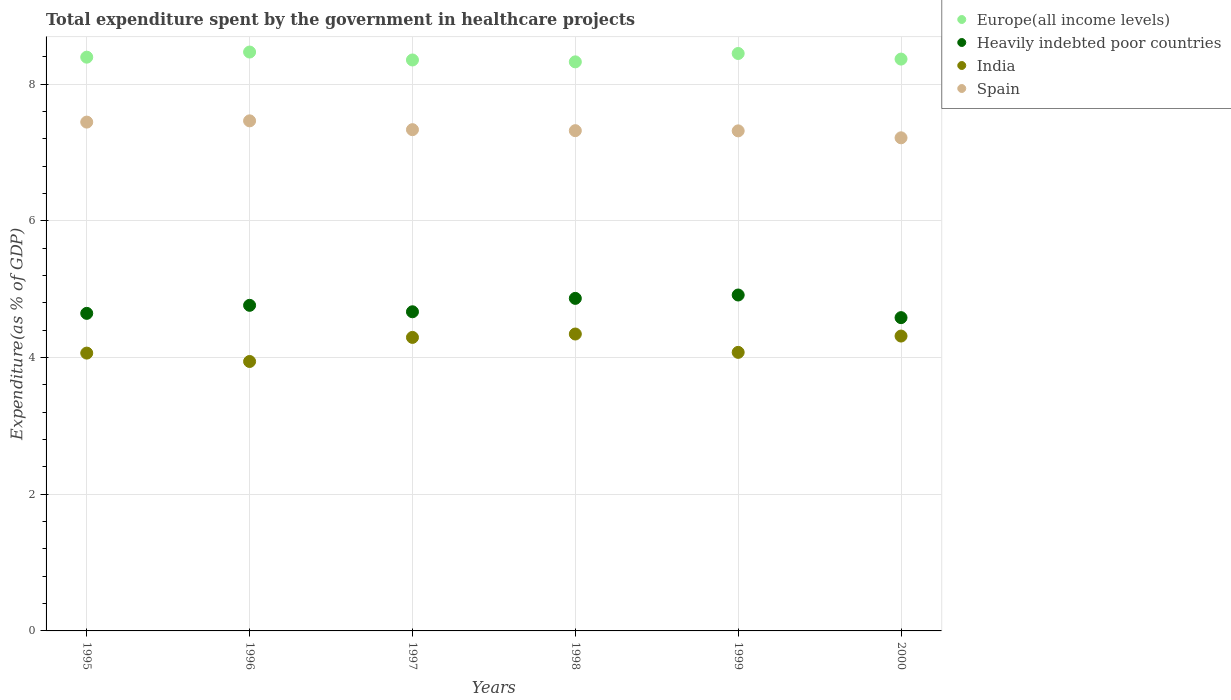How many different coloured dotlines are there?
Your answer should be compact. 4. What is the total expenditure spent by the government in healthcare projects in India in 1995?
Provide a succinct answer. 4.06. Across all years, what is the maximum total expenditure spent by the government in healthcare projects in India?
Offer a terse response. 4.34. Across all years, what is the minimum total expenditure spent by the government in healthcare projects in Europe(all income levels)?
Make the answer very short. 8.33. In which year was the total expenditure spent by the government in healthcare projects in Europe(all income levels) maximum?
Provide a succinct answer. 1996. In which year was the total expenditure spent by the government in healthcare projects in Spain minimum?
Provide a short and direct response. 2000. What is the total total expenditure spent by the government in healthcare projects in Spain in the graph?
Make the answer very short. 44.09. What is the difference between the total expenditure spent by the government in healthcare projects in India in 1996 and that in 1999?
Your answer should be compact. -0.13. What is the difference between the total expenditure spent by the government in healthcare projects in Europe(all income levels) in 1998 and the total expenditure spent by the government in healthcare projects in Spain in 2000?
Offer a very short reply. 1.11. What is the average total expenditure spent by the government in healthcare projects in Spain per year?
Your answer should be compact. 7.35. In the year 1996, what is the difference between the total expenditure spent by the government in healthcare projects in India and total expenditure spent by the government in healthcare projects in Europe(all income levels)?
Keep it short and to the point. -4.53. What is the ratio of the total expenditure spent by the government in healthcare projects in Spain in 1996 to that in 1998?
Give a very brief answer. 1.02. Is the total expenditure spent by the government in healthcare projects in India in 1997 less than that in 1998?
Ensure brevity in your answer.  Yes. What is the difference between the highest and the second highest total expenditure spent by the government in healthcare projects in Spain?
Provide a short and direct response. 0.02. What is the difference between the highest and the lowest total expenditure spent by the government in healthcare projects in Spain?
Offer a terse response. 0.25. Is it the case that in every year, the sum of the total expenditure spent by the government in healthcare projects in Spain and total expenditure spent by the government in healthcare projects in Heavily indebted poor countries  is greater than the sum of total expenditure spent by the government in healthcare projects in Europe(all income levels) and total expenditure spent by the government in healthcare projects in India?
Give a very brief answer. No. Is it the case that in every year, the sum of the total expenditure spent by the government in healthcare projects in Europe(all income levels) and total expenditure spent by the government in healthcare projects in Heavily indebted poor countries  is greater than the total expenditure spent by the government in healthcare projects in India?
Offer a terse response. Yes. Is the total expenditure spent by the government in healthcare projects in Europe(all income levels) strictly greater than the total expenditure spent by the government in healthcare projects in India over the years?
Offer a terse response. Yes. Is the total expenditure spent by the government in healthcare projects in Heavily indebted poor countries strictly less than the total expenditure spent by the government in healthcare projects in Spain over the years?
Give a very brief answer. Yes. How many years are there in the graph?
Keep it short and to the point. 6. Does the graph contain grids?
Offer a very short reply. Yes. Where does the legend appear in the graph?
Offer a terse response. Top right. How are the legend labels stacked?
Offer a terse response. Vertical. What is the title of the graph?
Provide a short and direct response. Total expenditure spent by the government in healthcare projects. What is the label or title of the Y-axis?
Make the answer very short. Expenditure(as % of GDP). What is the Expenditure(as % of GDP) of Europe(all income levels) in 1995?
Your answer should be very brief. 8.39. What is the Expenditure(as % of GDP) of Heavily indebted poor countries in 1995?
Your response must be concise. 4.65. What is the Expenditure(as % of GDP) in India in 1995?
Your answer should be compact. 4.06. What is the Expenditure(as % of GDP) of Spain in 1995?
Your response must be concise. 7.44. What is the Expenditure(as % of GDP) in Europe(all income levels) in 1996?
Your answer should be compact. 8.47. What is the Expenditure(as % of GDP) of Heavily indebted poor countries in 1996?
Offer a very short reply. 4.76. What is the Expenditure(as % of GDP) in India in 1996?
Provide a succinct answer. 3.94. What is the Expenditure(as % of GDP) of Spain in 1996?
Provide a short and direct response. 7.46. What is the Expenditure(as % of GDP) in Europe(all income levels) in 1997?
Ensure brevity in your answer.  8.35. What is the Expenditure(as % of GDP) of Heavily indebted poor countries in 1997?
Make the answer very short. 4.67. What is the Expenditure(as % of GDP) in India in 1997?
Provide a succinct answer. 4.29. What is the Expenditure(as % of GDP) of Spain in 1997?
Provide a short and direct response. 7.33. What is the Expenditure(as % of GDP) of Europe(all income levels) in 1998?
Your response must be concise. 8.33. What is the Expenditure(as % of GDP) in Heavily indebted poor countries in 1998?
Provide a succinct answer. 4.87. What is the Expenditure(as % of GDP) in India in 1998?
Offer a terse response. 4.34. What is the Expenditure(as % of GDP) in Spain in 1998?
Your answer should be compact. 7.32. What is the Expenditure(as % of GDP) in Europe(all income levels) in 1999?
Offer a very short reply. 8.45. What is the Expenditure(as % of GDP) in Heavily indebted poor countries in 1999?
Your answer should be compact. 4.91. What is the Expenditure(as % of GDP) of India in 1999?
Offer a very short reply. 4.08. What is the Expenditure(as % of GDP) of Spain in 1999?
Your response must be concise. 7.32. What is the Expenditure(as % of GDP) of Europe(all income levels) in 2000?
Provide a succinct answer. 8.37. What is the Expenditure(as % of GDP) in Heavily indebted poor countries in 2000?
Provide a short and direct response. 4.58. What is the Expenditure(as % of GDP) of India in 2000?
Provide a succinct answer. 4.31. What is the Expenditure(as % of GDP) in Spain in 2000?
Keep it short and to the point. 7.21. Across all years, what is the maximum Expenditure(as % of GDP) of Europe(all income levels)?
Your answer should be compact. 8.47. Across all years, what is the maximum Expenditure(as % of GDP) in Heavily indebted poor countries?
Your response must be concise. 4.91. Across all years, what is the maximum Expenditure(as % of GDP) in India?
Offer a very short reply. 4.34. Across all years, what is the maximum Expenditure(as % of GDP) in Spain?
Offer a terse response. 7.46. Across all years, what is the minimum Expenditure(as % of GDP) in Europe(all income levels)?
Ensure brevity in your answer.  8.33. Across all years, what is the minimum Expenditure(as % of GDP) in Heavily indebted poor countries?
Keep it short and to the point. 4.58. Across all years, what is the minimum Expenditure(as % of GDP) of India?
Ensure brevity in your answer.  3.94. Across all years, what is the minimum Expenditure(as % of GDP) of Spain?
Offer a terse response. 7.21. What is the total Expenditure(as % of GDP) of Europe(all income levels) in the graph?
Keep it short and to the point. 50.36. What is the total Expenditure(as % of GDP) of Heavily indebted poor countries in the graph?
Offer a terse response. 28.44. What is the total Expenditure(as % of GDP) in India in the graph?
Your response must be concise. 25.04. What is the total Expenditure(as % of GDP) in Spain in the graph?
Provide a short and direct response. 44.09. What is the difference between the Expenditure(as % of GDP) in Europe(all income levels) in 1995 and that in 1996?
Keep it short and to the point. -0.07. What is the difference between the Expenditure(as % of GDP) in Heavily indebted poor countries in 1995 and that in 1996?
Your answer should be very brief. -0.12. What is the difference between the Expenditure(as % of GDP) in India in 1995 and that in 1996?
Offer a terse response. 0.12. What is the difference between the Expenditure(as % of GDP) of Spain in 1995 and that in 1996?
Keep it short and to the point. -0.02. What is the difference between the Expenditure(as % of GDP) in Europe(all income levels) in 1995 and that in 1997?
Offer a very short reply. 0.04. What is the difference between the Expenditure(as % of GDP) in Heavily indebted poor countries in 1995 and that in 1997?
Provide a short and direct response. -0.02. What is the difference between the Expenditure(as % of GDP) of India in 1995 and that in 1997?
Provide a short and direct response. -0.23. What is the difference between the Expenditure(as % of GDP) of Spain in 1995 and that in 1997?
Provide a succinct answer. 0.11. What is the difference between the Expenditure(as % of GDP) in Europe(all income levels) in 1995 and that in 1998?
Keep it short and to the point. 0.07. What is the difference between the Expenditure(as % of GDP) in Heavily indebted poor countries in 1995 and that in 1998?
Ensure brevity in your answer.  -0.22. What is the difference between the Expenditure(as % of GDP) in India in 1995 and that in 1998?
Your answer should be very brief. -0.28. What is the difference between the Expenditure(as % of GDP) of Spain in 1995 and that in 1998?
Your answer should be compact. 0.13. What is the difference between the Expenditure(as % of GDP) in Europe(all income levels) in 1995 and that in 1999?
Offer a terse response. -0.05. What is the difference between the Expenditure(as % of GDP) of Heavily indebted poor countries in 1995 and that in 1999?
Make the answer very short. -0.27. What is the difference between the Expenditure(as % of GDP) in India in 1995 and that in 1999?
Offer a very short reply. -0.01. What is the difference between the Expenditure(as % of GDP) of Spain in 1995 and that in 1999?
Ensure brevity in your answer.  0.13. What is the difference between the Expenditure(as % of GDP) in Europe(all income levels) in 1995 and that in 2000?
Provide a succinct answer. 0.03. What is the difference between the Expenditure(as % of GDP) of Heavily indebted poor countries in 1995 and that in 2000?
Provide a short and direct response. 0.06. What is the difference between the Expenditure(as % of GDP) in India in 1995 and that in 2000?
Offer a terse response. -0.25. What is the difference between the Expenditure(as % of GDP) in Spain in 1995 and that in 2000?
Give a very brief answer. 0.23. What is the difference between the Expenditure(as % of GDP) of Europe(all income levels) in 1996 and that in 1997?
Give a very brief answer. 0.12. What is the difference between the Expenditure(as % of GDP) of Heavily indebted poor countries in 1996 and that in 1997?
Ensure brevity in your answer.  0.09. What is the difference between the Expenditure(as % of GDP) in India in 1996 and that in 1997?
Offer a very short reply. -0.35. What is the difference between the Expenditure(as % of GDP) of Spain in 1996 and that in 1997?
Your answer should be very brief. 0.13. What is the difference between the Expenditure(as % of GDP) in Europe(all income levels) in 1996 and that in 1998?
Provide a short and direct response. 0.14. What is the difference between the Expenditure(as % of GDP) of Heavily indebted poor countries in 1996 and that in 1998?
Give a very brief answer. -0.1. What is the difference between the Expenditure(as % of GDP) in India in 1996 and that in 1998?
Your response must be concise. -0.4. What is the difference between the Expenditure(as % of GDP) in Spain in 1996 and that in 1998?
Keep it short and to the point. 0.14. What is the difference between the Expenditure(as % of GDP) in Europe(all income levels) in 1996 and that in 1999?
Provide a succinct answer. 0.02. What is the difference between the Expenditure(as % of GDP) of Heavily indebted poor countries in 1996 and that in 1999?
Provide a succinct answer. -0.15. What is the difference between the Expenditure(as % of GDP) of India in 1996 and that in 1999?
Offer a terse response. -0.13. What is the difference between the Expenditure(as % of GDP) in Spain in 1996 and that in 1999?
Offer a very short reply. 0.15. What is the difference between the Expenditure(as % of GDP) in Europe(all income levels) in 1996 and that in 2000?
Make the answer very short. 0.1. What is the difference between the Expenditure(as % of GDP) in Heavily indebted poor countries in 1996 and that in 2000?
Ensure brevity in your answer.  0.18. What is the difference between the Expenditure(as % of GDP) of India in 1996 and that in 2000?
Provide a succinct answer. -0.37. What is the difference between the Expenditure(as % of GDP) in Spain in 1996 and that in 2000?
Provide a short and direct response. 0.25. What is the difference between the Expenditure(as % of GDP) of Europe(all income levels) in 1997 and that in 1998?
Provide a short and direct response. 0.03. What is the difference between the Expenditure(as % of GDP) of Heavily indebted poor countries in 1997 and that in 1998?
Provide a short and direct response. -0.2. What is the difference between the Expenditure(as % of GDP) of India in 1997 and that in 1998?
Your answer should be very brief. -0.05. What is the difference between the Expenditure(as % of GDP) of Spain in 1997 and that in 1998?
Your answer should be compact. 0.01. What is the difference between the Expenditure(as % of GDP) in Europe(all income levels) in 1997 and that in 1999?
Offer a very short reply. -0.1. What is the difference between the Expenditure(as % of GDP) in Heavily indebted poor countries in 1997 and that in 1999?
Make the answer very short. -0.25. What is the difference between the Expenditure(as % of GDP) of India in 1997 and that in 1999?
Offer a terse response. 0.22. What is the difference between the Expenditure(as % of GDP) of Spain in 1997 and that in 1999?
Ensure brevity in your answer.  0.02. What is the difference between the Expenditure(as % of GDP) in Europe(all income levels) in 1997 and that in 2000?
Ensure brevity in your answer.  -0.01. What is the difference between the Expenditure(as % of GDP) of Heavily indebted poor countries in 1997 and that in 2000?
Your response must be concise. 0.09. What is the difference between the Expenditure(as % of GDP) in India in 1997 and that in 2000?
Your answer should be compact. -0.02. What is the difference between the Expenditure(as % of GDP) of Spain in 1997 and that in 2000?
Provide a succinct answer. 0.12. What is the difference between the Expenditure(as % of GDP) of Europe(all income levels) in 1998 and that in 1999?
Your answer should be very brief. -0.12. What is the difference between the Expenditure(as % of GDP) of Heavily indebted poor countries in 1998 and that in 1999?
Make the answer very short. -0.05. What is the difference between the Expenditure(as % of GDP) in India in 1998 and that in 1999?
Your response must be concise. 0.27. What is the difference between the Expenditure(as % of GDP) of Spain in 1998 and that in 1999?
Provide a short and direct response. 0. What is the difference between the Expenditure(as % of GDP) in Europe(all income levels) in 1998 and that in 2000?
Make the answer very short. -0.04. What is the difference between the Expenditure(as % of GDP) of Heavily indebted poor countries in 1998 and that in 2000?
Offer a very short reply. 0.28. What is the difference between the Expenditure(as % of GDP) in India in 1998 and that in 2000?
Offer a very short reply. 0.03. What is the difference between the Expenditure(as % of GDP) of Spain in 1998 and that in 2000?
Your response must be concise. 0.1. What is the difference between the Expenditure(as % of GDP) in Europe(all income levels) in 1999 and that in 2000?
Your response must be concise. 0.08. What is the difference between the Expenditure(as % of GDP) of Heavily indebted poor countries in 1999 and that in 2000?
Make the answer very short. 0.33. What is the difference between the Expenditure(as % of GDP) in India in 1999 and that in 2000?
Your answer should be compact. -0.24. What is the difference between the Expenditure(as % of GDP) in Spain in 1999 and that in 2000?
Offer a terse response. 0.1. What is the difference between the Expenditure(as % of GDP) of Europe(all income levels) in 1995 and the Expenditure(as % of GDP) of Heavily indebted poor countries in 1996?
Offer a very short reply. 3.63. What is the difference between the Expenditure(as % of GDP) of Europe(all income levels) in 1995 and the Expenditure(as % of GDP) of India in 1996?
Provide a short and direct response. 4.45. What is the difference between the Expenditure(as % of GDP) in Europe(all income levels) in 1995 and the Expenditure(as % of GDP) in Spain in 1996?
Ensure brevity in your answer.  0.93. What is the difference between the Expenditure(as % of GDP) of Heavily indebted poor countries in 1995 and the Expenditure(as % of GDP) of India in 1996?
Offer a terse response. 0.7. What is the difference between the Expenditure(as % of GDP) in Heavily indebted poor countries in 1995 and the Expenditure(as % of GDP) in Spain in 1996?
Provide a short and direct response. -2.82. What is the difference between the Expenditure(as % of GDP) in India in 1995 and the Expenditure(as % of GDP) in Spain in 1996?
Offer a very short reply. -3.4. What is the difference between the Expenditure(as % of GDP) in Europe(all income levels) in 1995 and the Expenditure(as % of GDP) in Heavily indebted poor countries in 1997?
Make the answer very short. 3.73. What is the difference between the Expenditure(as % of GDP) of Europe(all income levels) in 1995 and the Expenditure(as % of GDP) of India in 1997?
Offer a very short reply. 4.1. What is the difference between the Expenditure(as % of GDP) of Europe(all income levels) in 1995 and the Expenditure(as % of GDP) of Spain in 1997?
Ensure brevity in your answer.  1.06. What is the difference between the Expenditure(as % of GDP) of Heavily indebted poor countries in 1995 and the Expenditure(as % of GDP) of India in 1997?
Offer a very short reply. 0.35. What is the difference between the Expenditure(as % of GDP) in Heavily indebted poor countries in 1995 and the Expenditure(as % of GDP) in Spain in 1997?
Your response must be concise. -2.69. What is the difference between the Expenditure(as % of GDP) of India in 1995 and the Expenditure(as % of GDP) of Spain in 1997?
Your response must be concise. -3.27. What is the difference between the Expenditure(as % of GDP) in Europe(all income levels) in 1995 and the Expenditure(as % of GDP) in Heavily indebted poor countries in 1998?
Your response must be concise. 3.53. What is the difference between the Expenditure(as % of GDP) in Europe(all income levels) in 1995 and the Expenditure(as % of GDP) in India in 1998?
Your answer should be compact. 4.05. What is the difference between the Expenditure(as % of GDP) in Europe(all income levels) in 1995 and the Expenditure(as % of GDP) in Spain in 1998?
Keep it short and to the point. 1.08. What is the difference between the Expenditure(as % of GDP) of Heavily indebted poor countries in 1995 and the Expenditure(as % of GDP) of India in 1998?
Keep it short and to the point. 0.3. What is the difference between the Expenditure(as % of GDP) of Heavily indebted poor countries in 1995 and the Expenditure(as % of GDP) of Spain in 1998?
Give a very brief answer. -2.67. What is the difference between the Expenditure(as % of GDP) of India in 1995 and the Expenditure(as % of GDP) of Spain in 1998?
Offer a terse response. -3.25. What is the difference between the Expenditure(as % of GDP) of Europe(all income levels) in 1995 and the Expenditure(as % of GDP) of Heavily indebted poor countries in 1999?
Your answer should be very brief. 3.48. What is the difference between the Expenditure(as % of GDP) in Europe(all income levels) in 1995 and the Expenditure(as % of GDP) in India in 1999?
Make the answer very short. 4.32. What is the difference between the Expenditure(as % of GDP) in Europe(all income levels) in 1995 and the Expenditure(as % of GDP) in Spain in 1999?
Provide a short and direct response. 1.08. What is the difference between the Expenditure(as % of GDP) of Heavily indebted poor countries in 1995 and the Expenditure(as % of GDP) of India in 1999?
Give a very brief answer. 0.57. What is the difference between the Expenditure(as % of GDP) in Heavily indebted poor countries in 1995 and the Expenditure(as % of GDP) in Spain in 1999?
Offer a very short reply. -2.67. What is the difference between the Expenditure(as % of GDP) in India in 1995 and the Expenditure(as % of GDP) in Spain in 1999?
Keep it short and to the point. -3.25. What is the difference between the Expenditure(as % of GDP) in Europe(all income levels) in 1995 and the Expenditure(as % of GDP) in Heavily indebted poor countries in 2000?
Keep it short and to the point. 3.81. What is the difference between the Expenditure(as % of GDP) in Europe(all income levels) in 1995 and the Expenditure(as % of GDP) in India in 2000?
Make the answer very short. 4.08. What is the difference between the Expenditure(as % of GDP) in Europe(all income levels) in 1995 and the Expenditure(as % of GDP) in Spain in 2000?
Offer a terse response. 1.18. What is the difference between the Expenditure(as % of GDP) of Heavily indebted poor countries in 1995 and the Expenditure(as % of GDP) of India in 2000?
Offer a terse response. 0.33. What is the difference between the Expenditure(as % of GDP) in Heavily indebted poor countries in 1995 and the Expenditure(as % of GDP) in Spain in 2000?
Your response must be concise. -2.57. What is the difference between the Expenditure(as % of GDP) in India in 1995 and the Expenditure(as % of GDP) in Spain in 2000?
Provide a short and direct response. -3.15. What is the difference between the Expenditure(as % of GDP) in Europe(all income levels) in 1996 and the Expenditure(as % of GDP) in Heavily indebted poor countries in 1997?
Ensure brevity in your answer.  3.8. What is the difference between the Expenditure(as % of GDP) of Europe(all income levels) in 1996 and the Expenditure(as % of GDP) of India in 1997?
Your answer should be compact. 4.18. What is the difference between the Expenditure(as % of GDP) in Europe(all income levels) in 1996 and the Expenditure(as % of GDP) in Spain in 1997?
Make the answer very short. 1.14. What is the difference between the Expenditure(as % of GDP) of Heavily indebted poor countries in 1996 and the Expenditure(as % of GDP) of India in 1997?
Your answer should be very brief. 0.47. What is the difference between the Expenditure(as % of GDP) of Heavily indebted poor countries in 1996 and the Expenditure(as % of GDP) of Spain in 1997?
Give a very brief answer. -2.57. What is the difference between the Expenditure(as % of GDP) in India in 1996 and the Expenditure(as % of GDP) in Spain in 1997?
Your answer should be compact. -3.39. What is the difference between the Expenditure(as % of GDP) in Europe(all income levels) in 1996 and the Expenditure(as % of GDP) in Heavily indebted poor countries in 1998?
Keep it short and to the point. 3.6. What is the difference between the Expenditure(as % of GDP) in Europe(all income levels) in 1996 and the Expenditure(as % of GDP) in India in 1998?
Provide a short and direct response. 4.13. What is the difference between the Expenditure(as % of GDP) in Europe(all income levels) in 1996 and the Expenditure(as % of GDP) in Spain in 1998?
Keep it short and to the point. 1.15. What is the difference between the Expenditure(as % of GDP) of Heavily indebted poor countries in 1996 and the Expenditure(as % of GDP) of India in 1998?
Make the answer very short. 0.42. What is the difference between the Expenditure(as % of GDP) of Heavily indebted poor countries in 1996 and the Expenditure(as % of GDP) of Spain in 1998?
Offer a terse response. -2.56. What is the difference between the Expenditure(as % of GDP) in India in 1996 and the Expenditure(as % of GDP) in Spain in 1998?
Give a very brief answer. -3.38. What is the difference between the Expenditure(as % of GDP) of Europe(all income levels) in 1996 and the Expenditure(as % of GDP) of Heavily indebted poor countries in 1999?
Your response must be concise. 3.55. What is the difference between the Expenditure(as % of GDP) of Europe(all income levels) in 1996 and the Expenditure(as % of GDP) of India in 1999?
Your answer should be compact. 4.39. What is the difference between the Expenditure(as % of GDP) of Europe(all income levels) in 1996 and the Expenditure(as % of GDP) of Spain in 1999?
Keep it short and to the point. 1.15. What is the difference between the Expenditure(as % of GDP) in Heavily indebted poor countries in 1996 and the Expenditure(as % of GDP) in India in 1999?
Provide a short and direct response. 0.69. What is the difference between the Expenditure(as % of GDP) in Heavily indebted poor countries in 1996 and the Expenditure(as % of GDP) in Spain in 1999?
Make the answer very short. -2.55. What is the difference between the Expenditure(as % of GDP) in India in 1996 and the Expenditure(as % of GDP) in Spain in 1999?
Ensure brevity in your answer.  -3.37. What is the difference between the Expenditure(as % of GDP) in Europe(all income levels) in 1996 and the Expenditure(as % of GDP) in Heavily indebted poor countries in 2000?
Offer a terse response. 3.89. What is the difference between the Expenditure(as % of GDP) in Europe(all income levels) in 1996 and the Expenditure(as % of GDP) in India in 2000?
Make the answer very short. 4.16. What is the difference between the Expenditure(as % of GDP) of Europe(all income levels) in 1996 and the Expenditure(as % of GDP) of Spain in 2000?
Your answer should be very brief. 1.25. What is the difference between the Expenditure(as % of GDP) in Heavily indebted poor countries in 1996 and the Expenditure(as % of GDP) in India in 2000?
Provide a succinct answer. 0.45. What is the difference between the Expenditure(as % of GDP) in Heavily indebted poor countries in 1996 and the Expenditure(as % of GDP) in Spain in 2000?
Provide a short and direct response. -2.45. What is the difference between the Expenditure(as % of GDP) in India in 1996 and the Expenditure(as % of GDP) in Spain in 2000?
Make the answer very short. -3.27. What is the difference between the Expenditure(as % of GDP) of Europe(all income levels) in 1997 and the Expenditure(as % of GDP) of Heavily indebted poor countries in 1998?
Provide a succinct answer. 3.49. What is the difference between the Expenditure(as % of GDP) of Europe(all income levels) in 1997 and the Expenditure(as % of GDP) of India in 1998?
Give a very brief answer. 4.01. What is the difference between the Expenditure(as % of GDP) of Europe(all income levels) in 1997 and the Expenditure(as % of GDP) of Spain in 1998?
Your answer should be very brief. 1.03. What is the difference between the Expenditure(as % of GDP) of Heavily indebted poor countries in 1997 and the Expenditure(as % of GDP) of India in 1998?
Ensure brevity in your answer.  0.33. What is the difference between the Expenditure(as % of GDP) in Heavily indebted poor countries in 1997 and the Expenditure(as % of GDP) in Spain in 1998?
Your response must be concise. -2.65. What is the difference between the Expenditure(as % of GDP) in India in 1997 and the Expenditure(as % of GDP) in Spain in 1998?
Your answer should be compact. -3.02. What is the difference between the Expenditure(as % of GDP) in Europe(all income levels) in 1997 and the Expenditure(as % of GDP) in Heavily indebted poor countries in 1999?
Keep it short and to the point. 3.44. What is the difference between the Expenditure(as % of GDP) of Europe(all income levels) in 1997 and the Expenditure(as % of GDP) of India in 1999?
Ensure brevity in your answer.  4.28. What is the difference between the Expenditure(as % of GDP) in Europe(all income levels) in 1997 and the Expenditure(as % of GDP) in Spain in 1999?
Provide a short and direct response. 1.04. What is the difference between the Expenditure(as % of GDP) of Heavily indebted poor countries in 1997 and the Expenditure(as % of GDP) of India in 1999?
Ensure brevity in your answer.  0.59. What is the difference between the Expenditure(as % of GDP) of Heavily indebted poor countries in 1997 and the Expenditure(as % of GDP) of Spain in 1999?
Provide a succinct answer. -2.65. What is the difference between the Expenditure(as % of GDP) in India in 1997 and the Expenditure(as % of GDP) in Spain in 1999?
Provide a short and direct response. -3.02. What is the difference between the Expenditure(as % of GDP) of Europe(all income levels) in 1997 and the Expenditure(as % of GDP) of Heavily indebted poor countries in 2000?
Make the answer very short. 3.77. What is the difference between the Expenditure(as % of GDP) of Europe(all income levels) in 1997 and the Expenditure(as % of GDP) of India in 2000?
Offer a terse response. 4.04. What is the difference between the Expenditure(as % of GDP) in Europe(all income levels) in 1997 and the Expenditure(as % of GDP) in Spain in 2000?
Your answer should be compact. 1.14. What is the difference between the Expenditure(as % of GDP) in Heavily indebted poor countries in 1997 and the Expenditure(as % of GDP) in India in 2000?
Ensure brevity in your answer.  0.36. What is the difference between the Expenditure(as % of GDP) in Heavily indebted poor countries in 1997 and the Expenditure(as % of GDP) in Spain in 2000?
Ensure brevity in your answer.  -2.55. What is the difference between the Expenditure(as % of GDP) in India in 1997 and the Expenditure(as % of GDP) in Spain in 2000?
Your response must be concise. -2.92. What is the difference between the Expenditure(as % of GDP) in Europe(all income levels) in 1998 and the Expenditure(as % of GDP) in Heavily indebted poor countries in 1999?
Your response must be concise. 3.41. What is the difference between the Expenditure(as % of GDP) in Europe(all income levels) in 1998 and the Expenditure(as % of GDP) in India in 1999?
Offer a terse response. 4.25. What is the difference between the Expenditure(as % of GDP) of Europe(all income levels) in 1998 and the Expenditure(as % of GDP) of Spain in 1999?
Offer a terse response. 1.01. What is the difference between the Expenditure(as % of GDP) in Heavily indebted poor countries in 1998 and the Expenditure(as % of GDP) in India in 1999?
Your answer should be very brief. 0.79. What is the difference between the Expenditure(as % of GDP) of Heavily indebted poor countries in 1998 and the Expenditure(as % of GDP) of Spain in 1999?
Your response must be concise. -2.45. What is the difference between the Expenditure(as % of GDP) in India in 1998 and the Expenditure(as % of GDP) in Spain in 1999?
Your answer should be very brief. -2.97. What is the difference between the Expenditure(as % of GDP) of Europe(all income levels) in 1998 and the Expenditure(as % of GDP) of Heavily indebted poor countries in 2000?
Keep it short and to the point. 3.74. What is the difference between the Expenditure(as % of GDP) of Europe(all income levels) in 1998 and the Expenditure(as % of GDP) of India in 2000?
Offer a very short reply. 4.01. What is the difference between the Expenditure(as % of GDP) in Europe(all income levels) in 1998 and the Expenditure(as % of GDP) in Spain in 2000?
Ensure brevity in your answer.  1.11. What is the difference between the Expenditure(as % of GDP) in Heavily indebted poor countries in 1998 and the Expenditure(as % of GDP) in India in 2000?
Your answer should be very brief. 0.55. What is the difference between the Expenditure(as % of GDP) in Heavily indebted poor countries in 1998 and the Expenditure(as % of GDP) in Spain in 2000?
Offer a terse response. -2.35. What is the difference between the Expenditure(as % of GDP) in India in 1998 and the Expenditure(as % of GDP) in Spain in 2000?
Offer a terse response. -2.87. What is the difference between the Expenditure(as % of GDP) of Europe(all income levels) in 1999 and the Expenditure(as % of GDP) of Heavily indebted poor countries in 2000?
Ensure brevity in your answer.  3.86. What is the difference between the Expenditure(as % of GDP) in Europe(all income levels) in 1999 and the Expenditure(as % of GDP) in India in 2000?
Your answer should be compact. 4.13. What is the difference between the Expenditure(as % of GDP) in Europe(all income levels) in 1999 and the Expenditure(as % of GDP) in Spain in 2000?
Keep it short and to the point. 1.23. What is the difference between the Expenditure(as % of GDP) in Heavily indebted poor countries in 1999 and the Expenditure(as % of GDP) in India in 2000?
Offer a very short reply. 0.6. What is the difference between the Expenditure(as % of GDP) in Heavily indebted poor countries in 1999 and the Expenditure(as % of GDP) in Spain in 2000?
Make the answer very short. -2.3. What is the difference between the Expenditure(as % of GDP) in India in 1999 and the Expenditure(as % of GDP) in Spain in 2000?
Offer a very short reply. -3.14. What is the average Expenditure(as % of GDP) in Europe(all income levels) per year?
Your answer should be compact. 8.39. What is the average Expenditure(as % of GDP) in Heavily indebted poor countries per year?
Provide a short and direct response. 4.74. What is the average Expenditure(as % of GDP) in India per year?
Provide a short and direct response. 4.17. What is the average Expenditure(as % of GDP) in Spain per year?
Ensure brevity in your answer.  7.35. In the year 1995, what is the difference between the Expenditure(as % of GDP) of Europe(all income levels) and Expenditure(as % of GDP) of Heavily indebted poor countries?
Offer a very short reply. 3.75. In the year 1995, what is the difference between the Expenditure(as % of GDP) of Europe(all income levels) and Expenditure(as % of GDP) of India?
Provide a succinct answer. 4.33. In the year 1995, what is the difference between the Expenditure(as % of GDP) of Heavily indebted poor countries and Expenditure(as % of GDP) of India?
Offer a terse response. 0.58. In the year 1995, what is the difference between the Expenditure(as % of GDP) in Heavily indebted poor countries and Expenditure(as % of GDP) in Spain?
Your answer should be compact. -2.8. In the year 1995, what is the difference between the Expenditure(as % of GDP) in India and Expenditure(as % of GDP) in Spain?
Your answer should be very brief. -3.38. In the year 1996, what is the difference between the Expenditure(as % of GDP) of Europe(all income levels) and Expenditure(as % of GDP) of Heavily indebted poor countries?
Keep it short and to the point. 3.71. In the year 1996, what is the difference between the Expenditure(as % of GDP) in Europe(all income levels) and Expenditure(as % of GDP) in India?
Provide a short and direct response. 4.53. In the year 1996, what is the difference between the Expenditure(as % of GDP) of Europe(all income levels) and Expenditure(as % of GDP) of Spain?
Give a very brief answer. 1.01. In the year 1996, what is the difference between the Expenditure(as % of GDP) in Heavily indebted poor countries and Expenditure(as % of GDP) in India?
Offer a terse response. 0.82. In the year 1996, what is the difference between the Expenditure(as % of GDP) in Heavily indebted poor countries and Expenditure(as % of GDP) in Spain?
Offer a terse response. -2.7. In the year 1996, what is the difference between the Expenditure(as % of GDP) of India and Expenditure(as % of GDP) of Spain?
Your response must be concise. -3.52. In the year 1997, what is the difference between the Expenditure(as % of GDP) in Europe(all income levels) and Expenditure(as % of GDP) in Heavily indebted poor countries?
Provide a short and direct response. 3.68. In the year 1997, what is the difference between the Expenditure(as % of GDP) of Europe(all income levels) and Expenditure(as % of GDP) of India?
Make the answer very short. 4.06. In the year 1997, what is the difference between the Expenditure(as % of GDP) of Europe(all income levels) and Expenditure(as % of GDP) of Spain?
Your answer should be very brief. 1.02. In the year 1997, what is the difference between the Expenditure(as % of GDP) in Heavily indebted poor countries and Expenditure(as % of GDP) in Spain?
Provide a short and direct response. -2.66. In the year 1997, what is the difference between the Expenditure(as % of GDP) in India and Expenditure(as % of GDP) in Spain?
Provide a short and direct response. -3.04. In the year 1998, what is the difference between the Expenditure(as % of GDP) in Europe(all income levels) and Expenditure(as % of GDP) in Heavily indebted poor countries?
Provide a short and direct response. 3.46. In the year 1998, what is the difference between the Expenditure(as % of GDP) of Europe(all income levels) and Expenditure(as % of GDP) of India?
Offer a very short reply. 3.98. In the year 1998, what is the difference between the Expenditure(as % of GDP) in Europe(all income levels) and Expenditure(as % of GDP) in Spain?
Provide a succinct answer. 1.01. In the year 1998, what is the difference between the Expenditure(as % of GDP) of Heavily indebted poor countries and Expenditure(as % of GDP) of India?
Your answer should be compact. 0.52. In the year 1998, what is the difference between the Expenditure(as % of GDP) of Heavily indebted poor countries and Expenditure(as % of GDP) of Spain?
Provide a short and direct response. -2.45. In the year 1998, what is the difference between the Expenditure(as % of GDP) in India and Expenditure(as % of GDP) in Spain?
Your answer should be very brief. -2.98. In the year 1999, what is the difference between the Expenditure(as % of GDP) in Europe(all income levels) and Expenditure(as % of GDP) in Heavily indebted poor countries?
Your answer should be compact. 3.53. In the year 1999, what is the difference between the Expenditure(as % of GDP) in Europe(all income levels) and Expenditure(as % of GDP) in India?
Your answer should be compact. 4.37. In the year 1999, what is the difference between the Expenditure(as % of GDP) in Europe(all income levels) and Expenditure(as % of GDP) in Spain?
Make the answer very short. 1.13. In the year 1999, what is the difference between the Expenditure(as % of GDP) of Heavily indebted poor countries and Expenditure(as % of GDP) of India?
Provide a short and direct response. 0.84. In the year 1999, what is the difference between the Expenditure(as % of GDP) in Heavily indebted poor countries and Expenditure(as % of GDP) in Spain?
Give a very brief answer. -2.4. In the year 1999, what is the difference between the Expenditure(as % of GDP) of India and Expenditure(as % of GDP) of Spain?
Your response must be concise. -3.24. In the year 2000, what is the difference between the Expenditure(as % of GDP) in Europe(all income levels) and Expenditure(as % of GDP) in Heavily indebted poor countries?
Keep it short and to the point. 3.78. In the year 2000, what is the difference between the Expenditure(as % of GDP) in Europe(all income levels) and Expenditure(as % of GDP) in India?
Offer a very short reply. 4.05. In the year 2000, what is the difference between the Expenditure(as % of GDP) in Europe(all income levels) and Expenditure(as % of GDP) in Spain?
Your answer should be very brief. 1.15. In the year 2000, what is the difference between the Expenditure(as % of GDP) in Heavily indebted poor countries and Expenditure(as % of GDP) in India?
Make the answer very short. 0.27. In the year 2000, what is the difference between the Expenditure(as % of GDP) of Heavily indebted poor countries and Expenditure(as % of GDP) of Spain?
Your response must be concise. -2.63. In the year 2000, what is the difference between the Expenditure(as % of GDP) in India and Expenditure(as % of GDP) in Spain?
Your answer should be very brief. -2.9. What is the ratio of the Expenditure(as % of GDP) in Europe(all income levels) in 1995 to that in 1996?
Offer a terse response. 0.99. What is the ratio of the Expenditure(as % of GDP) of Heavily indebted poor countries in 1995 to that in 1996?
Ensure brevity in your answer.  0.98. What is the ratio of the Expenditure(as % of GDP) of India in 1995 to that in 1996?
Offer a very short reply. 1.03. What is the ratio of the Expenditure(as % of GDP) in Spain in 1995 to that in 1996?
Keep it short and to the point. 1. What is the ratio of the Expenditure(as % of GDP) of India in 1995 to that in 1997?
Keep it short and to the point. 0.95. What is the ratio of the Expenditure(as % of GDP) of Spain in 1995 to that in 1997?
Your answer should be compact. 1.02. What is the ratio of the Expenditure(as % of GDP) of Europe(all income levels) in 1995 to that in 1998?
Offer a very short reply. 1.01. What is the ratio of the Expenditure(as % of GDP) of Heavily indebted poor countries in 1995 to that in 1998?
Your answer should be compact. 0.95. What is the ratio of the Expenditure(as % of GDP) in India in 1995 to that in 1998?
Offer a terse response. 0.94. What is the ratio of the Expenditure(as % of GDP) of Spain in 1995 to that in 1998?
Your response must be concise. 1.02. What is the ratio of the Expenditure(as % of GDP) in Europe(all income levels) in 1995 to that in 1999?
Your answer should be compact. 0.99. What is the ratio of the Expenditure(as % of GDP) in Heavily indebted poor countries in 1995 to that in 1999?
Give a very brief answer. 0.95. What is the ratio of the Expenditure(as % of GDP) of India in 1995 to that in 1999?
Offer a very short reply. 1. What is the ratio of the Expenditure(as % of GDP) in Spain in 1995 to that in 1999?
Ensure brevity in your answer.  1.02. What is the ratio of the Expenditure(as % of GDP) of Heavily indebted poor countries in 1995 to that in 2000?
Make the answer very short. 1.01. What is the ratio of the Expenditure(as % of GDP) in India in 1995 to that in 2000?
Offer a very short reply. 0.94. What is the ratio of the Expenditure(as % of GDP) in Spain in 1995 to that in 2000?
Provide a short and direct response. 1.03. What is the ratio of the Expenditure(as % of GDP) in Europe(all income levels) in 1996 to that in 1997?
Provide a succinct answer. 1.01. What is the ratio of the Expenditure(as % of GDP) in Heavily indebted poor countries in 1996 to that in 1997?
Provide a succinct answer. 1.02. What is the ratio of the Expenditure(as % of GDP) of India in 1996 to that in 1997?
Offer a terse response. 0.92. What is the ratio of the Expenditure(as % of GDP) in Spain in 1996 to that in 1997?
Make the answer very short. 1.02. What is the ratio of the Expenditure(as % of GDP) in Europe(all income levels) in 1996 to that in 1998?
Offer a terse response. 1.02. What is the ratio of the Expenditure(as % of GDP) in Heavily indebted poor countries in 1996 to that in 1998?
Offer a very short reply. 0.98. What is the ratio of the Expenditure(as % of GDP) of India in 1996 to that in 1998?
Keep it short and to the point. 0.91. What is the ratio of the Expenditure(as % of GDP) of Spain in 1996 to that in 1998?
Keep it short and to the point. 1.02. What is the ratio of the Expenditure(as % of GDP) of Heavily indebted poor countries in 1996 to that in 1999?
Offer a very short reply. 0.97. What is the ratio of the Expenditure(as % of GDP) of India in 1996 to that in 1999?
Your response must be concise. 0.97. What is the ratio of the Expenditure(as % of GDP) in Spain in 1996 to that in 1999?
Make the answer very short. 1.02. What is the ratio of the Expenditure(as % of GDP) of Europe(all income levels) in 1996 to that in 2000?
Provide a short and direct response. 1.01. What is the ratio of the Expenditure(as % of GDP) in Heavily indebted poor countries in 1996 to that in 2000?
Provide a succinct answer. 1.04. What is the ratio of the Expenditure(as % of GDP) in India in 1996 to that in 2000?
Make the answer very short. 0.91. What is the ratio of the Expenditure(as % of GDP) of Spain in 1996 to that in 2000?
Provide a succinct answer. 1.03. What is the ratio of the Expenditure(as % of GDP) of Heavily indebted poor countries in 1997 to that in 1998?
Provide a succinct answer. 0.96. What is the ratio of the Expenditure(as % of GDP) of India in 1997 to that in 1998?
Make the answer very short. 0.99. What is the ratio of the Expenditure(as % of GDP) in Spain in 1997 to that in 1998?
Give a very brief answer. 1. What is the ratio of the Expenditure(as % of GDP) in Europe(all income levels) in 1997 to that in 1999?
Your answer should be compact. 0.99. What is the ratio of the Expenditure(as % of GDP) of Heavily indebted poor countries in 1997 to that in 1999?
Offer a terse response. 0.95. What is the ratio of the Expenditure(as % of GDP) in India in 1997 to that in 1999?
Your answer should be compact. 1.05. What is the ratio of the Expenditure(as % of GDP) in Spain in 1997 to that in 1999?
Offer a terse response. 1. What is the ratio of the Expenditure(as % of GDP) of Europe(all income levels) in 1997 to that in 2000?
Provide a succinct answer. 1. What is the ratio of the Expenditure(as % of GDP) in Heavily indebted poor countries in 1997 to that in 2000?
Provide a short and direct response. 1.02. What is the ratio of the Expenditure(as % of GDP) of Spain in 1997 to that in 2000?
Offer a very short reply. 1.02. What is the ratio of the Expenditure(as % of GDP) of Europe(all income levels) in 1998 to that in 1999?
Your answer should be very brief. 0.99. What is the ratio of the Expenditure(as % of GDP) of Heavily indebted poor countries in 1998 to that in 1999?
Your answer should be very brief. 0.99. What is the ratio of the Expenditure(as % of GDP) of India in 1998 to that in 1999?
Offer a very short reply. 1.07. What is the ratio of the Expenditure(as % of GDP) of Europe(all income levels) in 1998 to that in 2000?
Your answer should be very brief. 1. What is the ratio of the Expenditure(as % of GDP) in Heavily indebted poor countries in 1998 to that in 2000?
Your answer should be very brief. 1.06. What is the ratio of the Expenditure(as % of GDP) of India in 1998 to that in 2000?
Your answer should be compact. 1.01. What is the ratio of the Expenditure(as % of GDP) in Spain in 1998 to that in 2000?
Make the answer very short. 1.01. What is the ratio of the Expenditure(as % of GDP) of Europe(all income levels) in 1999 to that in 2000?
Your response must be concise. 1.01. What is the ratio of the Expenditure(as % of GDP) in Heavily indebted poor countries in 1999 to that in 2000?
Keep it short and to the point. 1.07. What is the ratio of the Expenditure(as % of GDP) in India in 1999 to that in 2000?
Keep it short and to the point. 0.94. What is the ratio of the Expenditure(as % of GDP) in Spain in 1999 to that in 2000?
Your response must be concise. 1.01. What is the difference between the highest and the second highest Expenditure(as % of GDP) in Europe(all income levels)?
Offer a very short reply. 0.02. What is the difference between the highest and the second highest Expenditure(as % of GDP) of Heavily indebted poor countries?
Offer a very short reply. 0.05. What is the difference between the highest and the second highest Expenditure(as % of GDP) of India?
Your answer should be compact. 0.03. What is the difference between the highest and the second highest Expenditure(as % of GDP) in Spain?
Provide a short and direct response. 0.02. What is the difference between the highest and the lowest Expenditure(as % of GDP) in Europe(all income levels)?
Your answer should be very brief. 0.14. What is the difference between the highest and the lowest Expenditure(as % of GDP) of Heavily indebted poor countries?
Your answer should be compact. 0.33. What is the difference between the highest and the lowest Expenditure(as % of GDP) in India?
Offer a terse response. 0.4. What is the difference between the highest and the lowest Expenditure(as % of GDP) in Spain?
Make the answer very short. 0.25. 